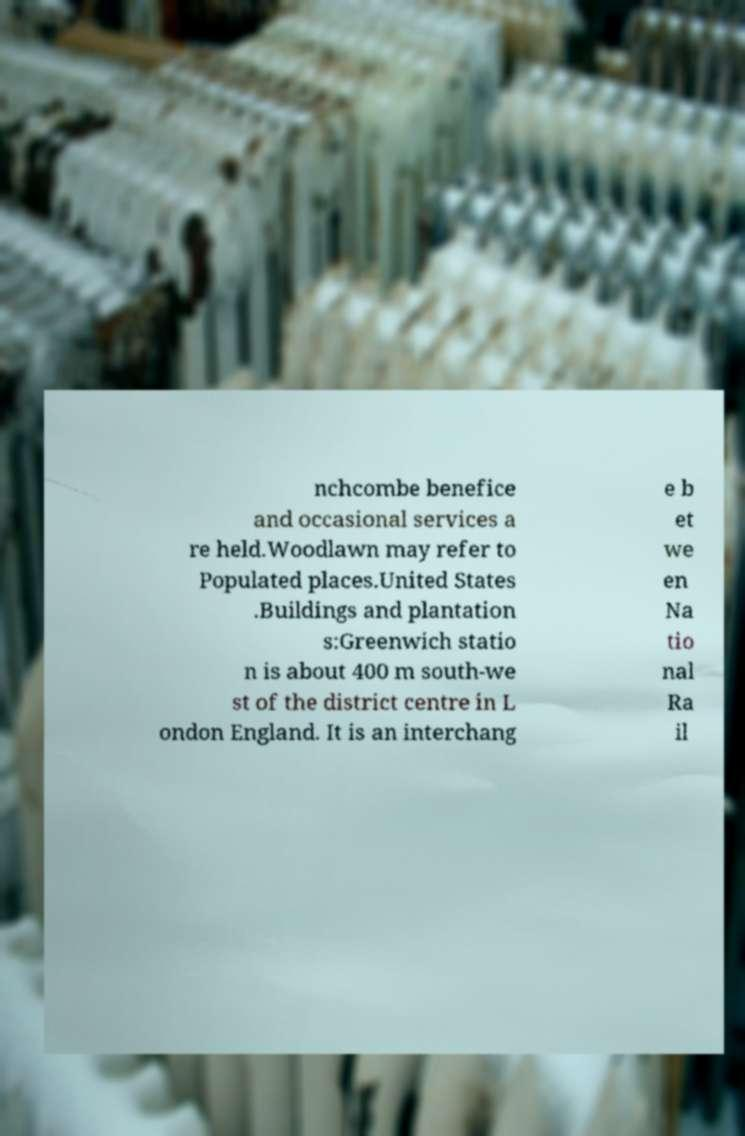What messages or text are displayed in this image? I need them in a readable, typed format. nchcombe benefice and occasional services a re held.Woodlawn may refer to Populated places.United States .Buildings and plantation s:Greenwich statio n is about 400 m south-we st of the district centre in L ondon England. It is an interchang e b et we en Na tio nal Ra il 